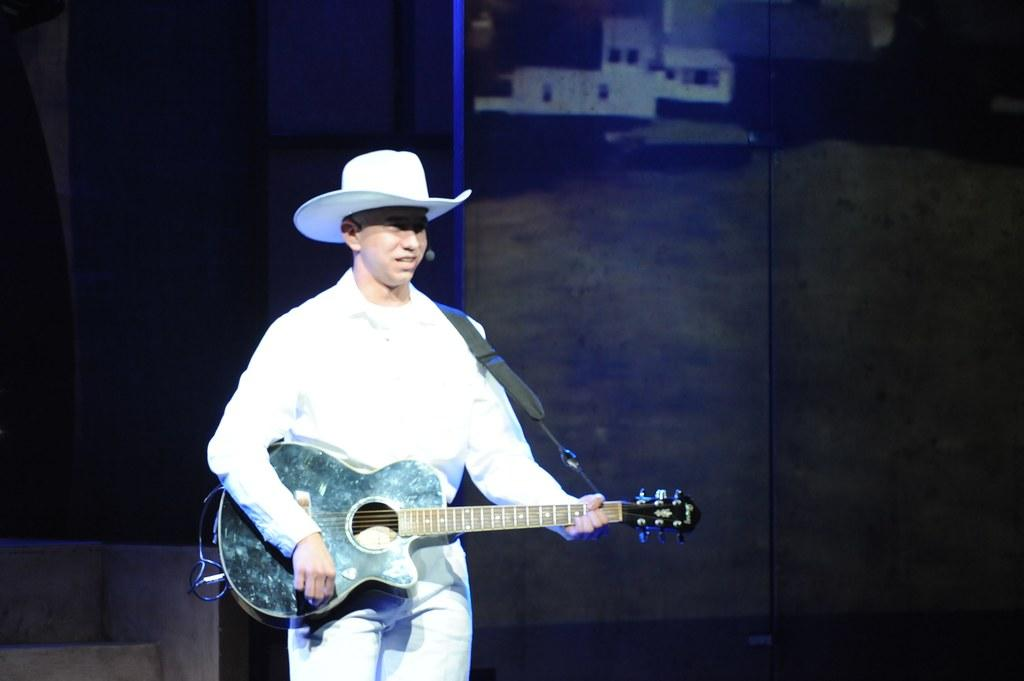What is the person in the image doing? The person is playing the guitar. What is the person wearing? The person is wearing a white shirt and white pants. What accessory is the person wearing on their head? The person is wearing a hat. How would you describe the background of the image? The background of the image is dark. How many roses are on the person's lap in the image? There are no roses present in the image; the person is playing the guitar. What company is the person representing in the image? There is no indication of a company in the image; it simply shows a person playing the guitar. 